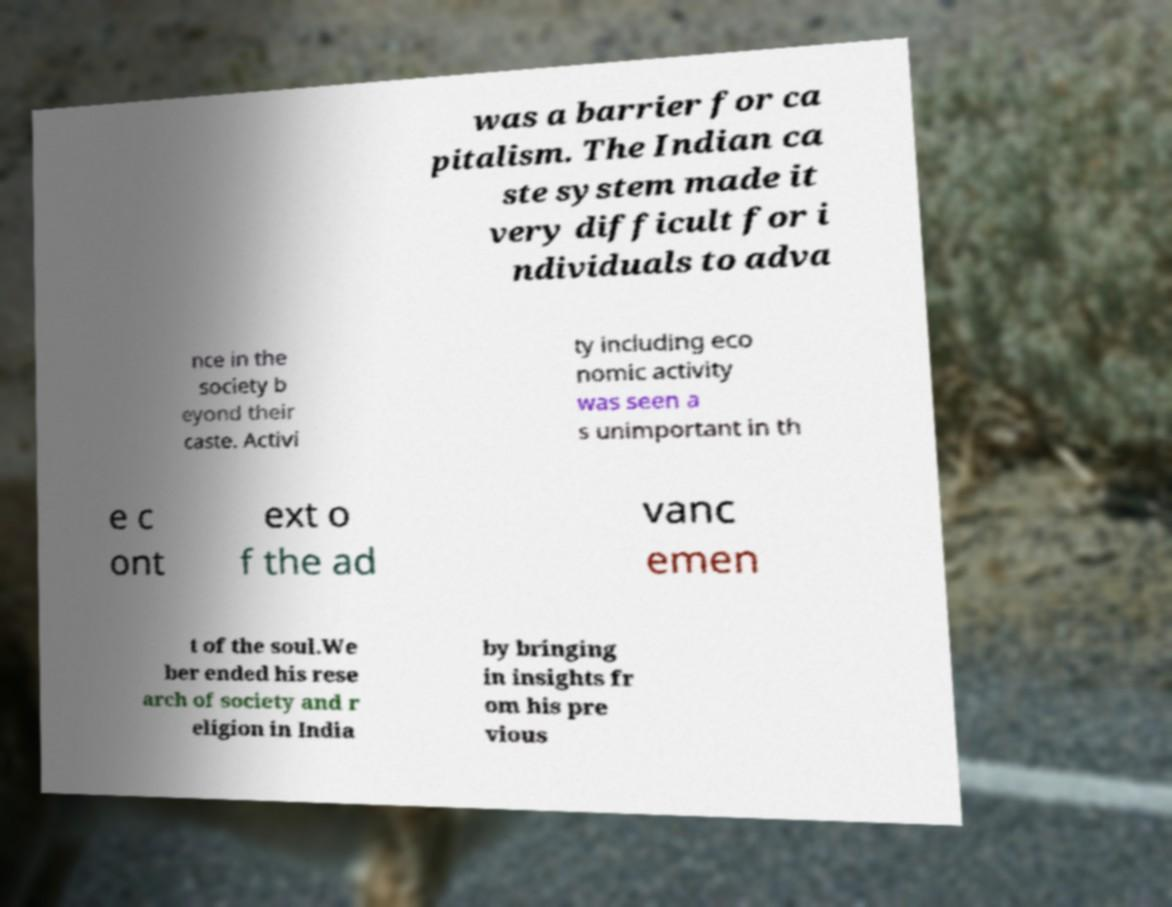Can you read and provide the text displayed in the image?This photo seems to have some interesting text. Can you extract and type it out for me? was a barrier for ca pitalism. The Indian ca ste system made it very difficult for i ndividuals to adva nce in the society b eyond their caste. Activi ty including eco nomic activity was seen a s unimportant in th e c ont ext o f the ad vanc emen t of the soul.We ber ended his rese arch of society and r eligion in India by bringing in insights fr om his pre vious 